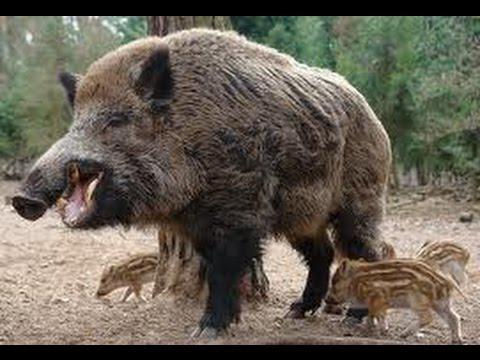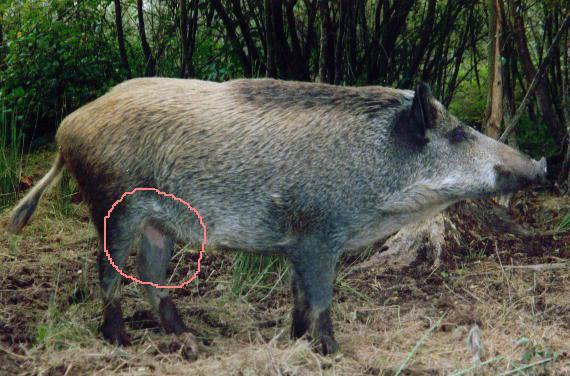The first image is the image on the left, the second image is the image on the right. For the images shown, is this caption "The left image shows only an adult boar, which is facing leftward." true? Answer yes or no. No. The first image is the image on the left, the second image is the image on the right. Assess this claim about the two images: "The hog on the right image is standing and facing right". Correct or not? Answer yes or no. Yes. 